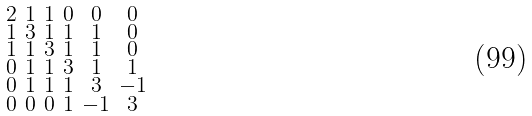<formula> <loc_0><loc_0><loc_500><loc_500>\begin{smallmatrix} 2 & 1 & 1 & 0 & 0 & 0 \\ 1 & 3 & 1 & 1 & 1 & 0 \\ 1 & 1 & 3 & 1 & 1 & 0 \\ 0 & 1 & 1 & 3 & 1 & 1 \\ 0 & 1 & 1 & 1 & 3 & - 1 \\ 0 & 0 & 0 & 1 & - 1 & 3 \end{smallmatrix}</formula> 